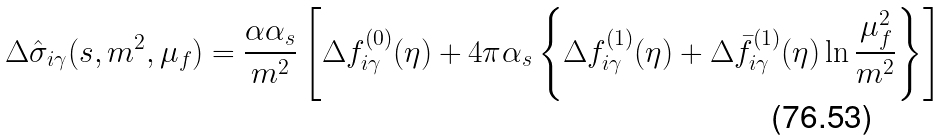<formula> <loc_0><loc_0><loc_500><loc_500>\Delta \hat { \sigma } _ { i \gamma } ( s , m ^ { 2 } , \mu _ { f } ) = \frac { \alpha \alpha _ { s } } { m ^ { 2 } } \left [ \Delta f _ { i \gamma } ^ { ( 0 ) } ( \eta ) + 4 \pi \alpha _ { s } \left \{ \Delta f _ { i \gamma } ^ { ( 1 ) } ( \eta ) + \Delta \bar { f } _ { i \gamma } ^ { ( 1 ) } ( \eta ) \ln \frac { \mu _ { f } ^ { 2 } } { m ^ { 2 } } \right \} \right ] \,</formula> 